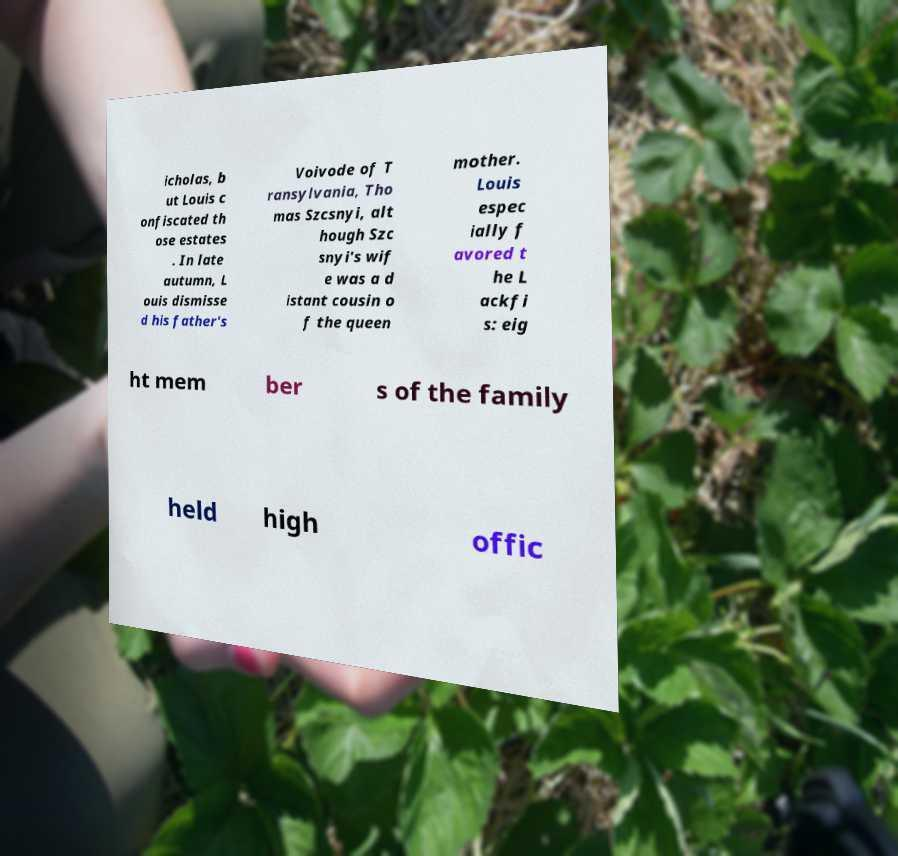Please identify and transcribe the text found in this image. icholas, b ut Louis c onfiscated th ose estates . In late autumn, L ouis dismisse d his father's Voivode of T ransylvania, Tho mas Szcsnyi, alt hough Szc snyi's wif e was a d istant cousin o f the queen mother. Louis espec ially f avored t he L ackfi s: eig ht mem ber s of the family held high offic 